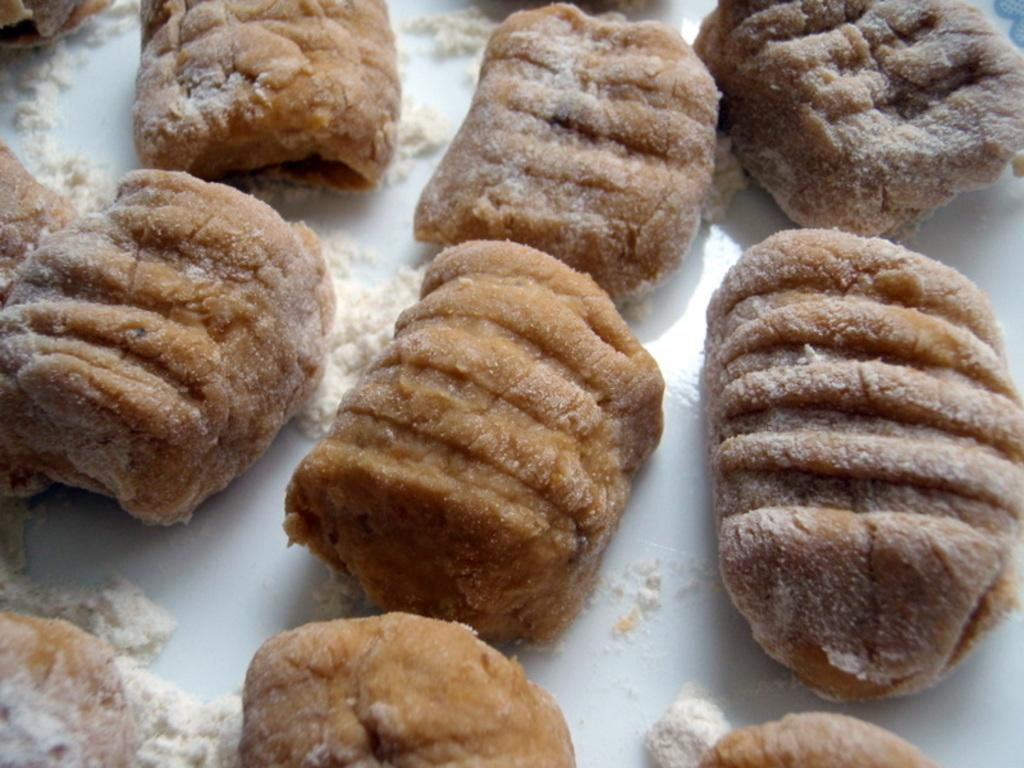What is located in the center of the image? There is a plate in the center of the image. What is on the plate? There are food items on the plate. What type of rat can be seen interacting with the food on the plate in the image? There is no rat present in the image, and therefore no such interaction can be observed. 